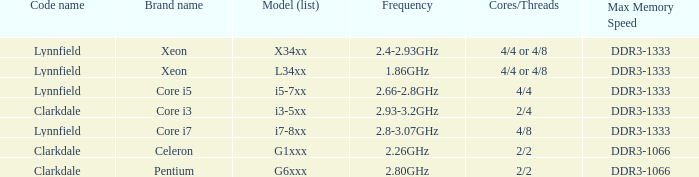List the number of cores for ddr3-1333 with frequencies between 2.66-2.8ghz. 4/4. I'm looking to parse the entire table for insights. Could you assist me with that? {'header': ['Code name', 'Brand name', 'Model (list)', 'Frequency', 'Cores/Threads', 'Max Memory Speed'], 'rows': [['Lynnfield', 'Xeon', 'X34xx', '2.4-2.93GHz', '4/4 or 4/8', 'DDR3-1333'], ['Lynnfield', 'Xeon', 'L34xx', '1.86GHz', '4/4 or 4/8', 'DDR3-1333'], ['Lynnfield', 'Core i5', 'i5-7xx', '2.66-2.8GHz', '4/4', 'DDR3-1333'], ['Clarkdale', 'Core i3', 'i3-5xx', '2.93-3.2GHz', '2/4', 'DDR3-1333'], ['Lynnfield', 'Core i7', 'i7-8xx', '2.8-3.07GHz', '4/8', 'DDR3-1333'], ['Clarkdale', 'Celeron', 'G1xxx', '2.26GHz', '2/2', 'DDR3-1066'], ['Clarkdale', 'Pentium', 'G6xxx', '2.80GHz', '2/2', 'DDR3-1066']]} 